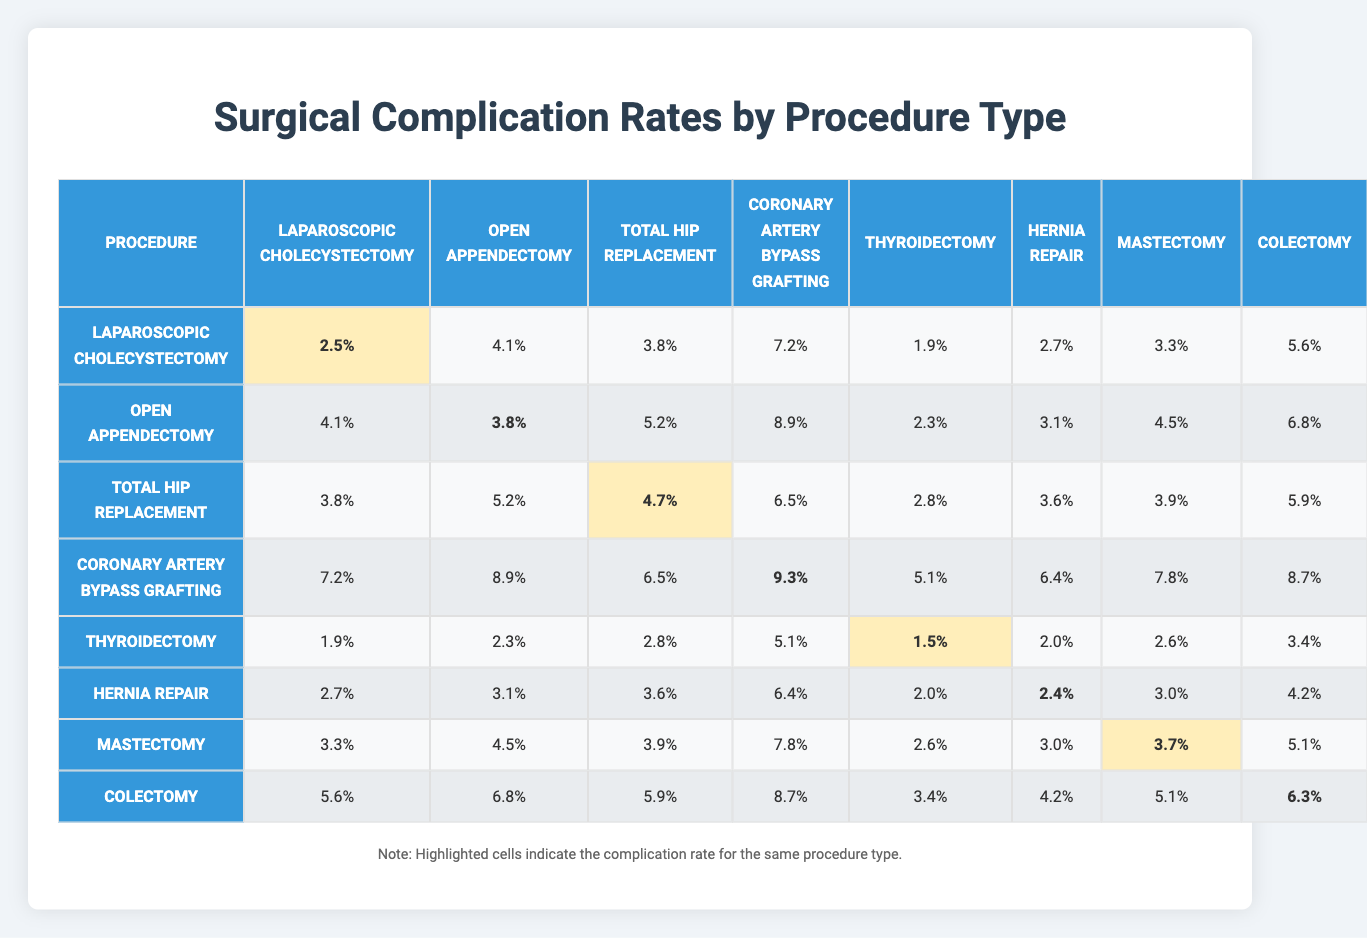What is the complication rate for Total Hip Replacement? Looking at the row for Total Hip Replacement in the table, the corresponding complication rate value is 4.7%.
Answer: 4.7% Which procedure has the highest complication rate? By scanning through the table, the procedure with the highest complication rate is Coronary Artery Bypass Grafting, which has a value of 9.3%.
Answer: Coronary Artery Bypass Grafting What is the average complication rate for Laparoscopic Cholecystectomy? The complication rates for Laparoscopic Cholecystectomy are: 2.5, 4.1, 3.8, 7.2, 1.9, 2.7, 3.3, 5.6. To find the average, sum these values: 2.5 + 4.1 + 3.8 + 7.2 + 1.9 + 2.7 + 3.3 + 5.6 = 31.1, then divide by 8 (the number of rates): 31.1 / 8 = 3.8875, which rounds to 3.89%.
Answer: 3.89% Is the complication rate for Thyroidectomy lower than that for Hernia Repair? The complication rate for Thyroidectomy is 1.5%, whereas for Hernia Repair it is 2.0%. Since 1.5% is less than 2.0%, the statement is true.
Answer: Yes What is the difference in complication rates between Colectomy and Mastectomy? The complication rate for Colectomy is 5.9% and for Mastectomy it is 3.7%. The difference is 5.9% - 3.7% = 2.2%.
Answer: 2.2% If a patient underwent Open Appendectomy, what is the chance that their complication rate is above 5%? The complication rates for Open Appendectomy are 4.1%, 3.8%, 5.2%, 8.9%, 2.3%, 3.1%, 4.5%, 6.8%. There are 3 rates (8.9%, 5.2%, and 6.8%) that are above 5%. To find the probability, we have 3 rates above 5% out of 8 total rates, which is 3/8 or 37.5%.
Answer: 37.5% What is the sum of complication rates for all procedures listed? To find the sum, we need to add all the rates across each procedure: (2.5+4.1+3.8+7.2+1.9+2.7+3.3+5.6) + (4.1+3.8+5.2+8.9+2.3+3.1+4.5+6.8) + ... + (5.6+6.8+5.9+8.7+3.4+4.2+5.1+6.3) = 60.1.
Answer: 60.1 Which procedure has the most consistent complication rates (smallest range)? To find the range, we check the highest and lowest rates for each procedure. After calculating, the ranges are: Laparoscopic Cholecystectomy (5.6 - 1.9 = 3.7), Open Appendectomy (8.9 - 2.3 = 6.6), Total Hip Replacement (6.5 - 2.8 = 3.7), and others. The smallest ranges are 3.7 for both Laparoscopic Cholecystectomy and Total Hip Replacement, indicating relatively consistent complication rates.
Answer: Laparoscopic Cholecystectomy and Total Hip Replacement Is there any procedure type with a consistent rate over 6% for all categories? By examining the rows, Total Hip Replacement shows rates above 6% in most categories (4 out of 8), but not all. However, only Coronary Artery Bypass Grafting has rates consistently over 6% across the board.
Answer: Yes 